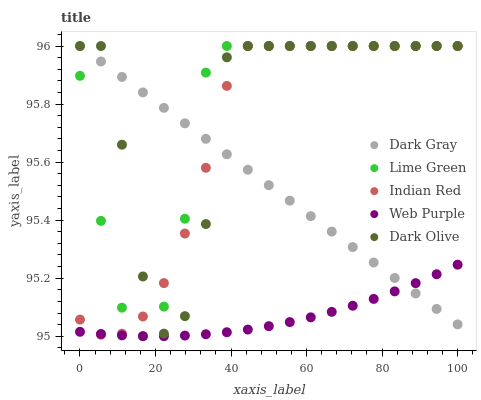Does Web Purple have the minimum area under the curve?
Answer yes or no. Yes. Does Dark Olive have the maximum area under the curve?
Answer yes or no. Yes. Does Dark Olive have the minimum area under the curve?
Answer yes or no. No. Does Web Purple have the maximum area under the curve?
Answer yes or no. No. Is Dark Gray the smoothest?
Answer yes or no. Yes. Is Dark Olive the roughest?
Answer yes or no. Yes. Is Web Purple the smoothest?
Answer yes or no. No. Is Web Purple the roughest?
Answer yes or no. No. Does Lime Green have the lowest value?
Answer yes or no. Yes. Does Web Purple have the lowest value?
Answer yes or no. No. Does Indian Red have the highest value?
Answer yes or no. Yes. Does Web Purple have the highest value?
Answer yes or no. No. Is Web Purple less than Dark Olive?
Answer yes or no. Yes. Is Dark Olive greater than Web Purple?
Answer yes or no. Yes. Does Web Purple intersect Dark Gray?
Answer yes or no. Yes. Is Web Purple less than Dark Gray?
Answer yes or no. No. Is Web Purple greater than Dark Gray?
Answer yes or no. No. Does Web Purple intersect Dark Olive?
Answer yes or no. No. 